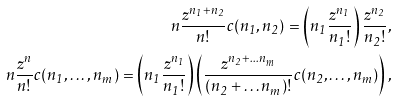Convert formula to latex. <formula><loc_0><loc_0><loc_500><loc_500>n \frac { z ^ { n _ { 1 } + n _ { 2 } } } { n ! } c ( n _ { 1 } , n _ { 2 } ) = \left ( n _ { 1 } \frac { z ^ { n _ { 1 } } } { n _ { 1 } ! } \right ) \frac { z ^ { n _ { 2 } } } { n _ { 2 } ! } , \\ n \frac { z ^ { n } } { n ! } c ( n _ { 1 } , \dots , n _ { m } ) = \left ( n _ { 1 } \frac { z ^ { n _ { 1 } } } { n _ { 1 } ! } \right ) \left ( \frac { z ^ { n _ { 2 } + \dots n _ { m } } } { ( n _ { 2 } + \dots n _ { m } ) ! } c ( n _ { 2 } , \dots , n _ { m } ) \right ) ,</formula> 